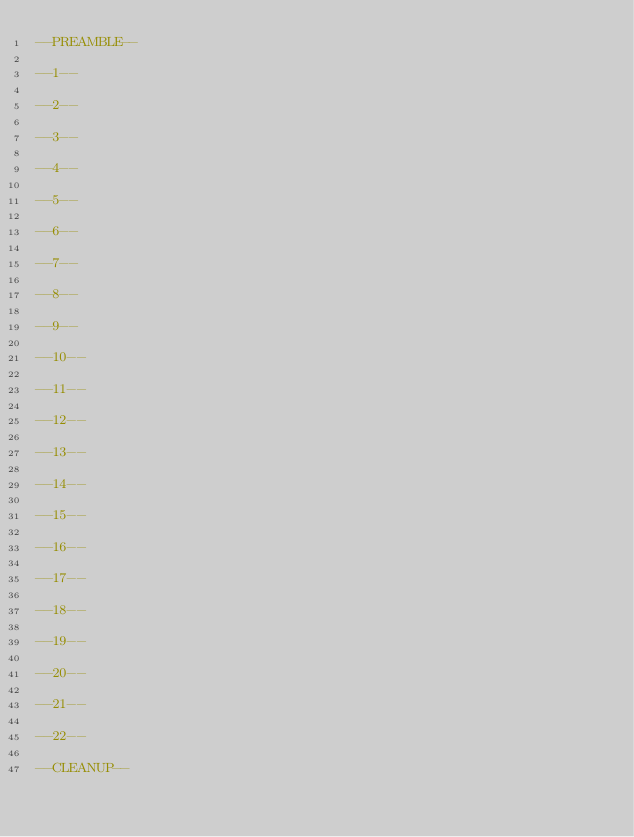<code> <loc_0><loc_0><loc_500><loc_500><_SQL_>--PREAMBLE--

--1--

--2--

--3--

--4--

--5--

--6--

--7--

--8--

--9--

--10--

--11--

--12--

--13--

--14--

--15--

--16--

--17--

--18--

--19--

--20--

--21--

--22--

--CLEANUP--
</code> 